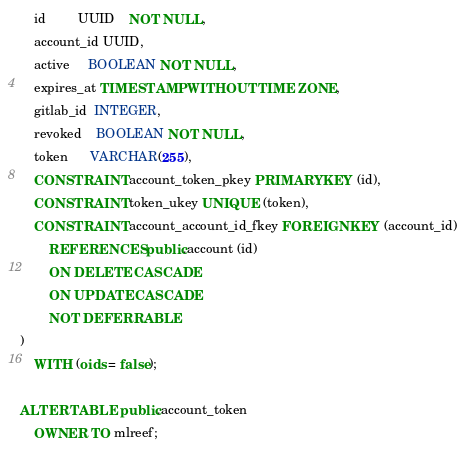Convert code to text. <code><loc_0><loc_0><loc_500><loc_500><_SQL_>    id         UUID    NOT NULL,
    account_id UUID,
    active     BOOLEAN NOT NULL,
    expires_at TIMESTAMP WITHOUT TIME ZONE,
    gitlab_id  INTEGER,
    revoked    BOOLEAN NOT NULL,
    token      VARCHAR(255),
    CONSTRAINT account_token_pkey PRIMARY KEY (id),
    CONSTRAINT token_ukey UNIQUE (token),
    CONSTRAINT account_account_id_fkey FOREIGN KEY (account_id)
        REFERENCES public.account (id)
        ON DELETE CASCADE
        ON UPDATE CASCADE
        NOT DEFERRABLE
)
    WITH (oids = false);

ALTER TABLE public.account_token
    OWNER TO mlreef;</code> 